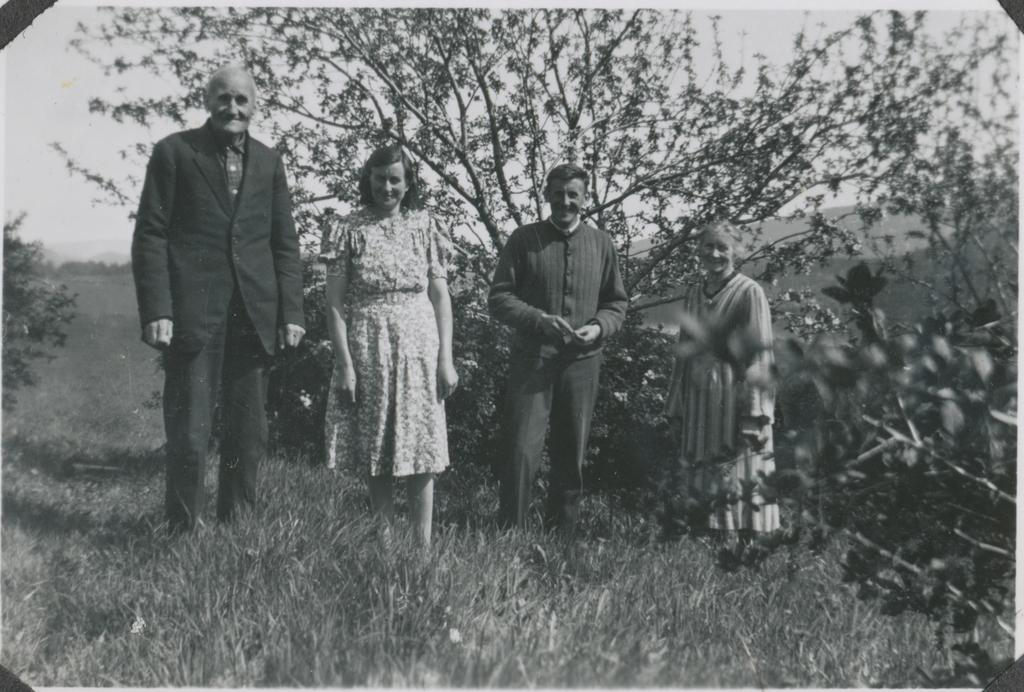What is the color scheme of the image? The image is black and white. How many people are present in the image? There are four people standing in the image. What is the ground surface like where the people are standing? The people are standing on grass. What can be seen in the background of the image? There are trees and the sky visible in the background of the image. How many bags can be seen in the image? There are no bags visible in the image. What type of lizards can be seen crawling on the people in the image? There are no lizards present in the image; the people are standing on grass with no animals visible. 